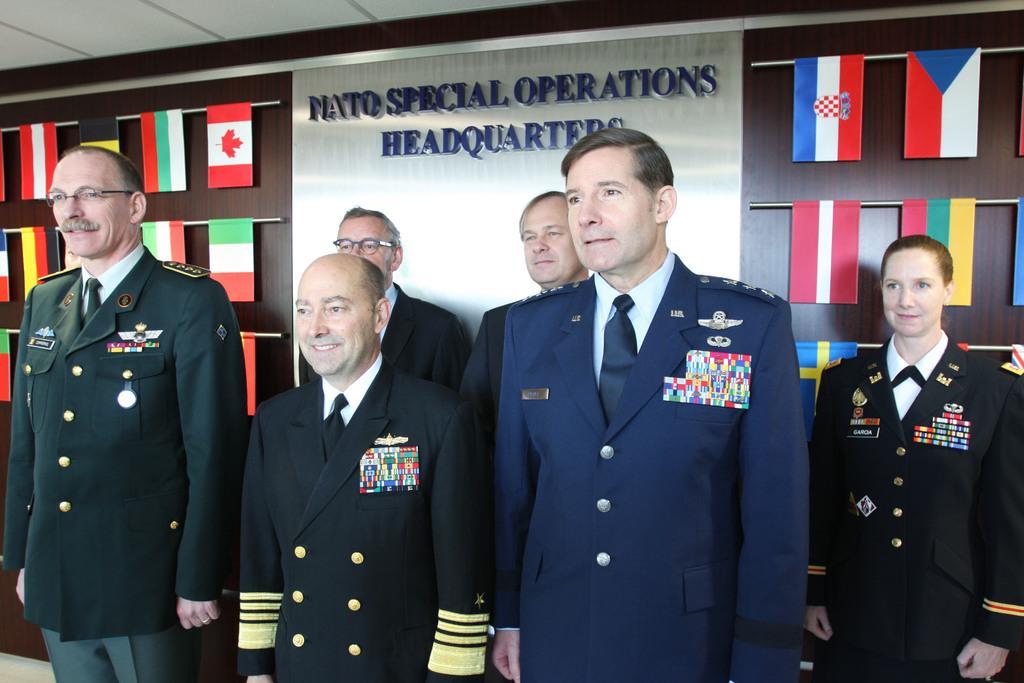Could you give a brief overview of what you see in this image? In this image I can see number of persons wearing uniforms are standing and in the background I can see the brown colored surface, number of flags and the ceiling. 